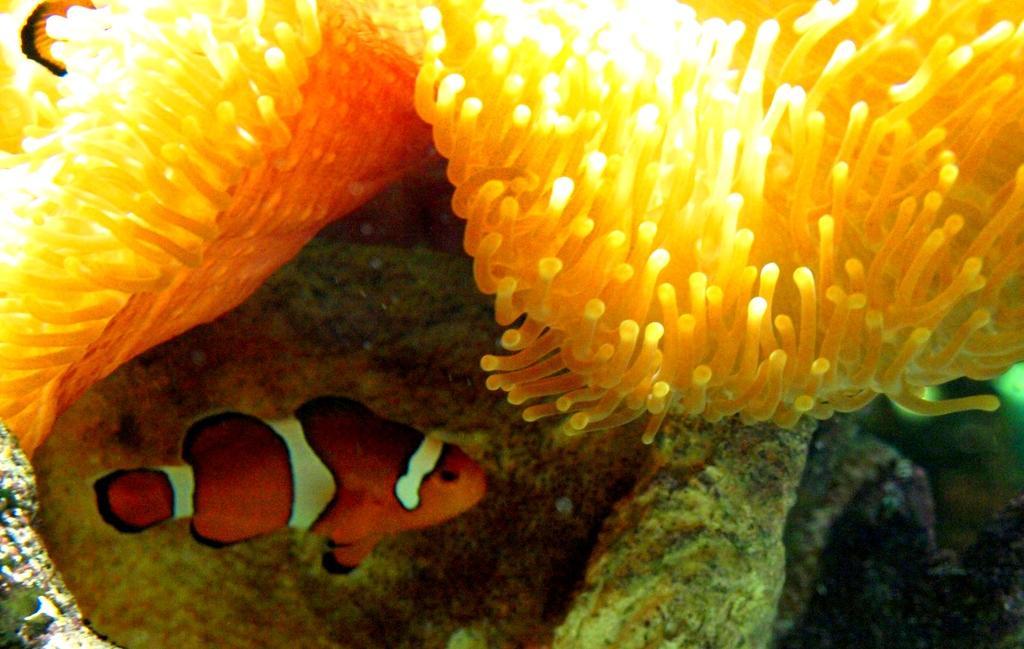Can you describe this image briefly? This is a zoomed in picture. In the foreground there is an orange color fish in the water body. At the top we can see the marine plants. In the background there are some objects. 